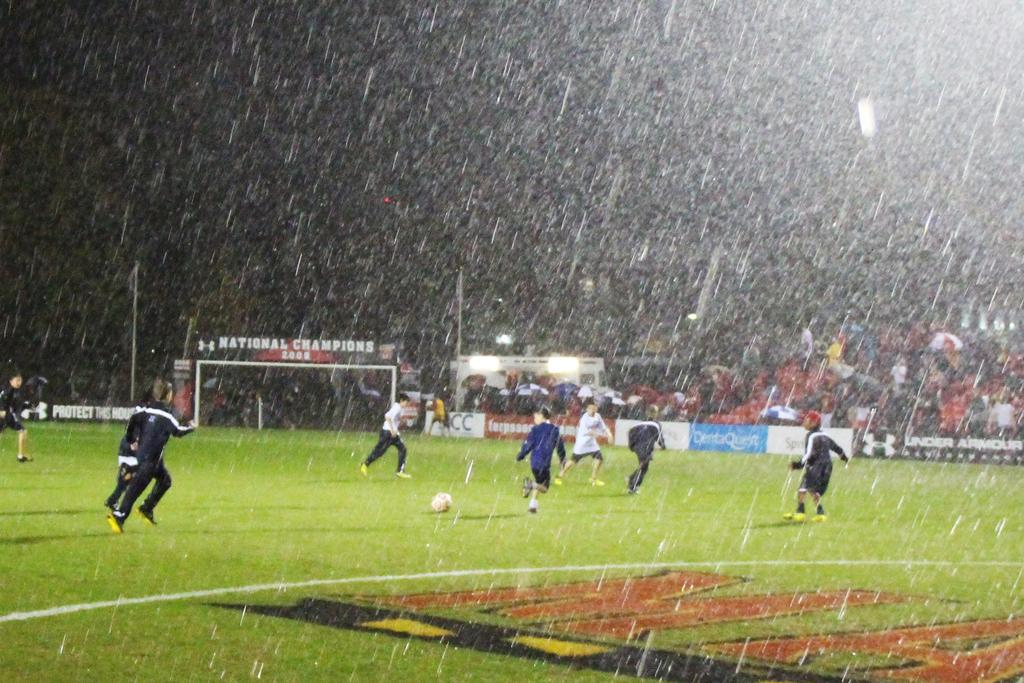<image>
Write a terse but informative summary of the picture. Players playing soccer in the rain at the field of the 2000 National Champions. 